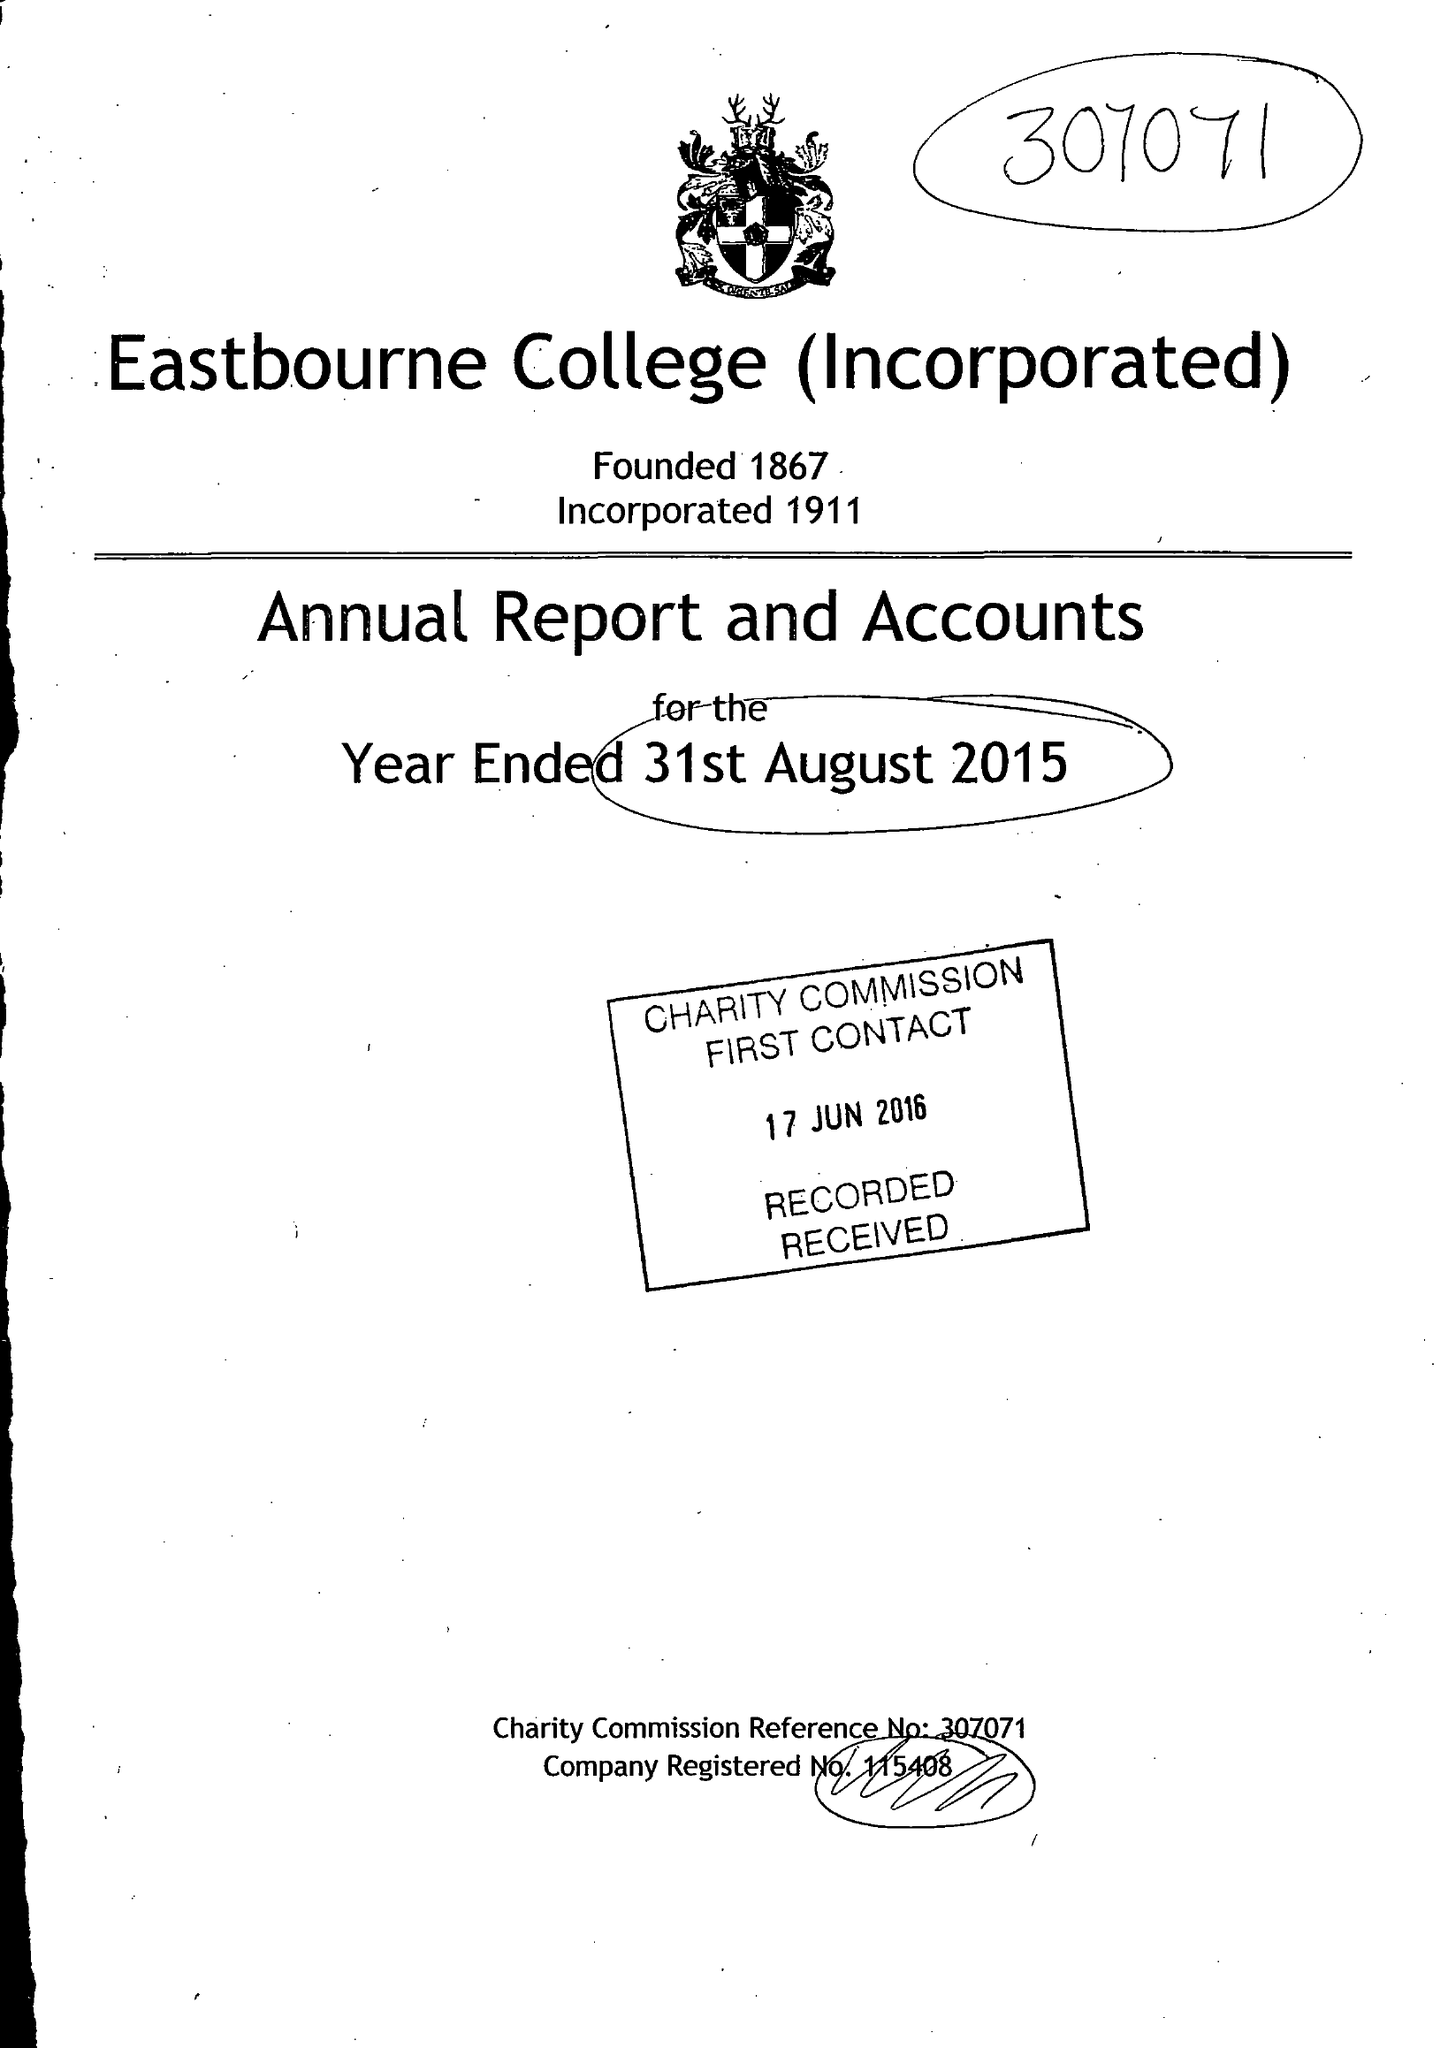What is the value for the charity_name?
Answer the question using a single word or phrase. Eastbourne College (Incorporated) 